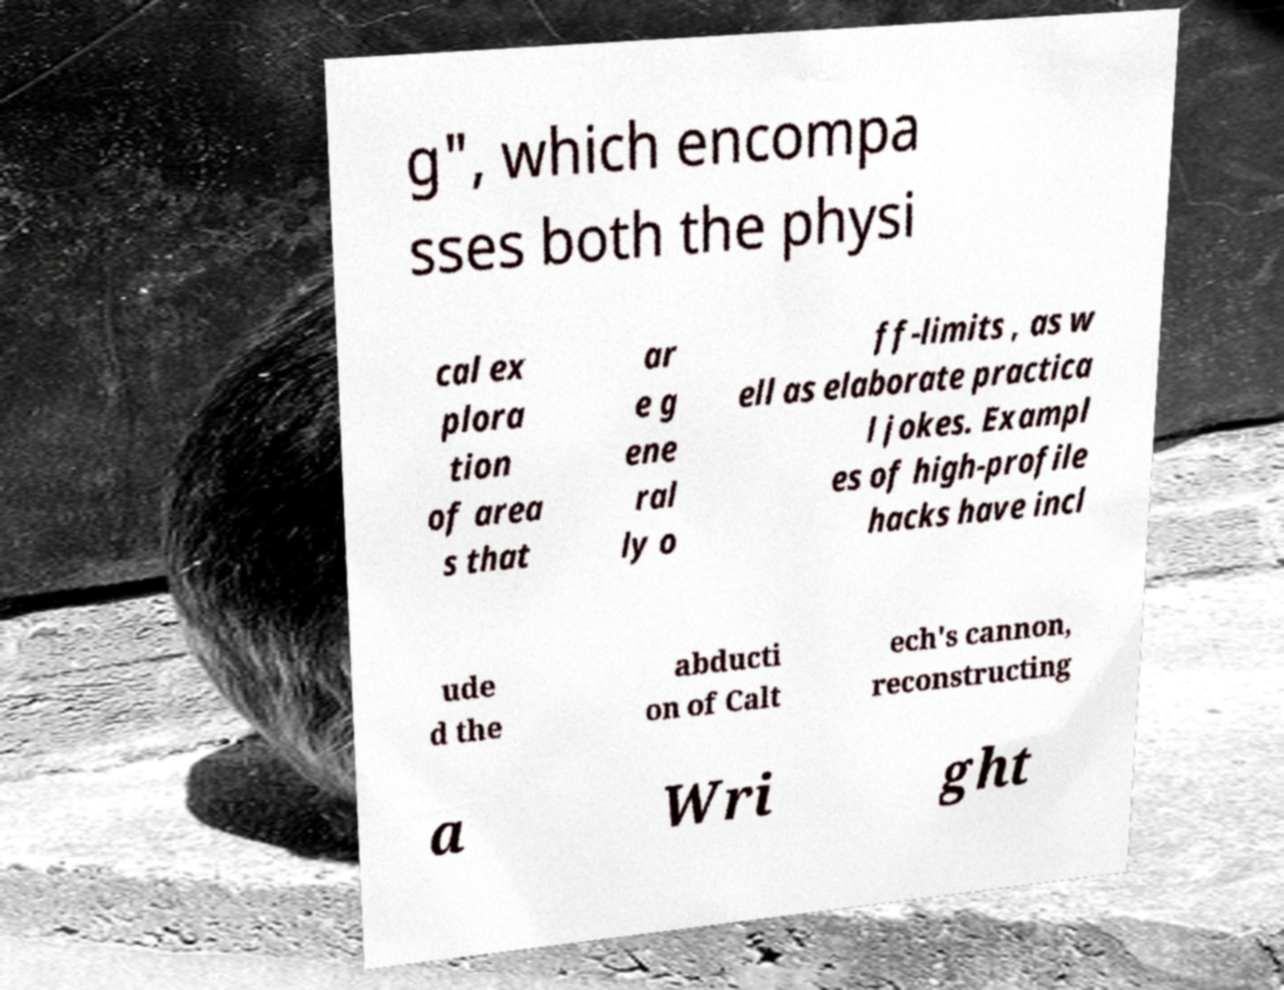What messages or text are displayed in this image? I need them in a readable, typed format. g", which encompa sses both the physi cal ex plora tion of area s that ar e g ene ral ly o ff-limits , as w ell as elaborate practica l jokes. Exampl es of high-profile hacks have incl ude d the abducti on of Calt ech's cannon, reconstructing a Wri ght 